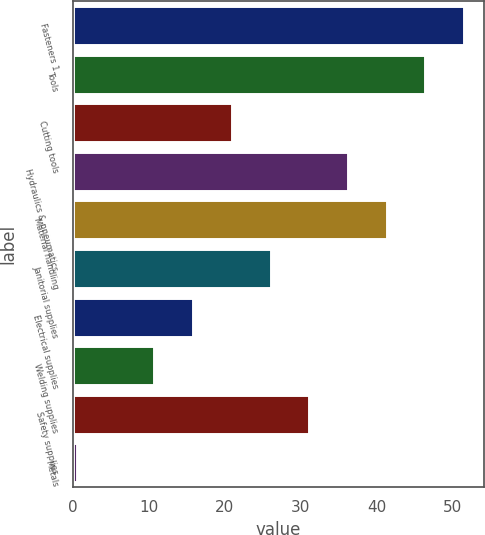Convert chart to OTSL. <chart><loc_0><loc_0><loc_500><loc_500><bar_chart><fcel>Fasteners 1<fcel>Tools<fcel>Cutting tools<fcel>Hydraulics & pneumatics<fcel>Material handling<fcel>Janitorial supplies<fcel>Electrical supplies<fcel>Welding supplies<fcel>Safety supplies<fcel>Metals<nl><fcel>51.5<fcel>46.41<fcel>20.96<fcel>36.23<fcel>41.32<fcel>26.05<fcel>15.87<fcel>10.78<fcel>31.14<fcel>0.6<nl></chart> 